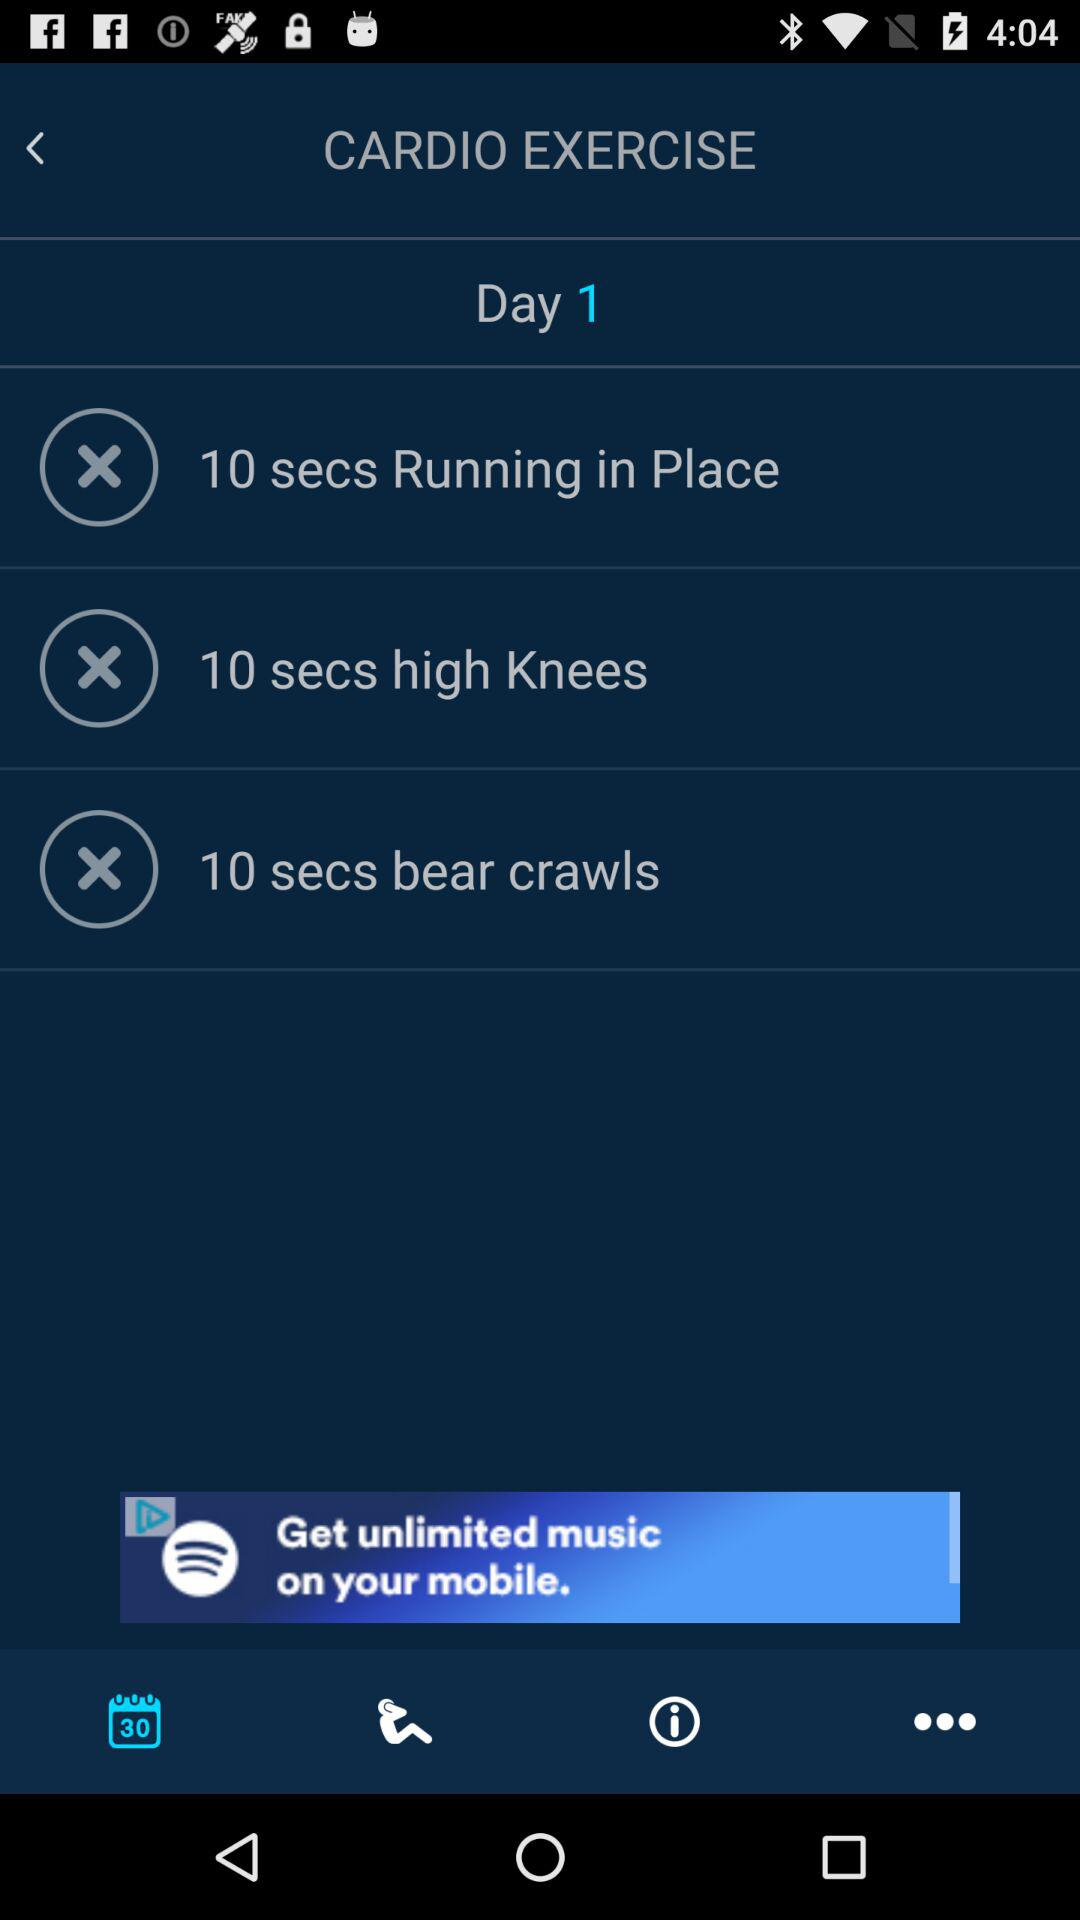How many exercises are there on this day?
Answer the question using a single word or phrase. 3 